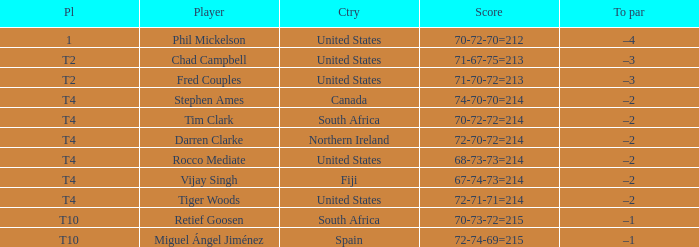What country does Rocco Mediate play for? United States. 